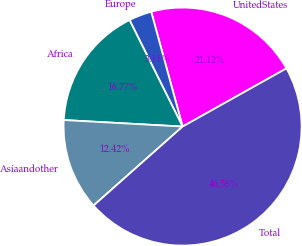<chart> <loc_0><loc_0><loc_500><loc_500><pie_chart><fcel>UnitedStates<fcel>Europe<fcel>Africa<fcel>Asiaandother<fcel>Total<nl><fcel>21.12%<fcel>3.11%<fcel>16.77%<fcel>12.42%<fcel>46.58%<nl></chart> 